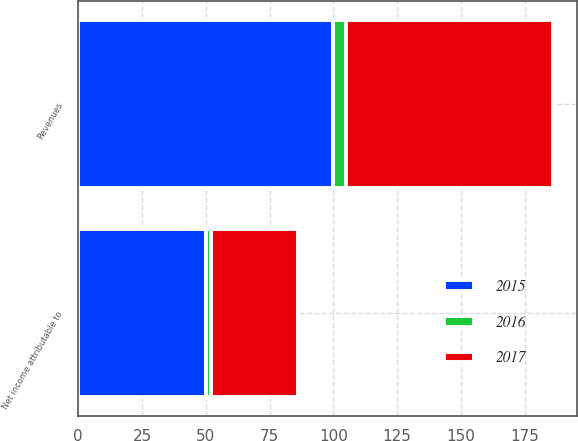Convert chart to OTSL. <chart><loc_0><loc_0><loc_500><loc_500><stacked_bar_chart><ecel><fcel>Revenues<fcel>Net income attributable to<nl><fcel>2017<fcel>81<fcel>34<nl><fcel>2016<fcel>5<fcel>2<nl><fcel>2015<fcel>100<fcel>50<nl></chart> 